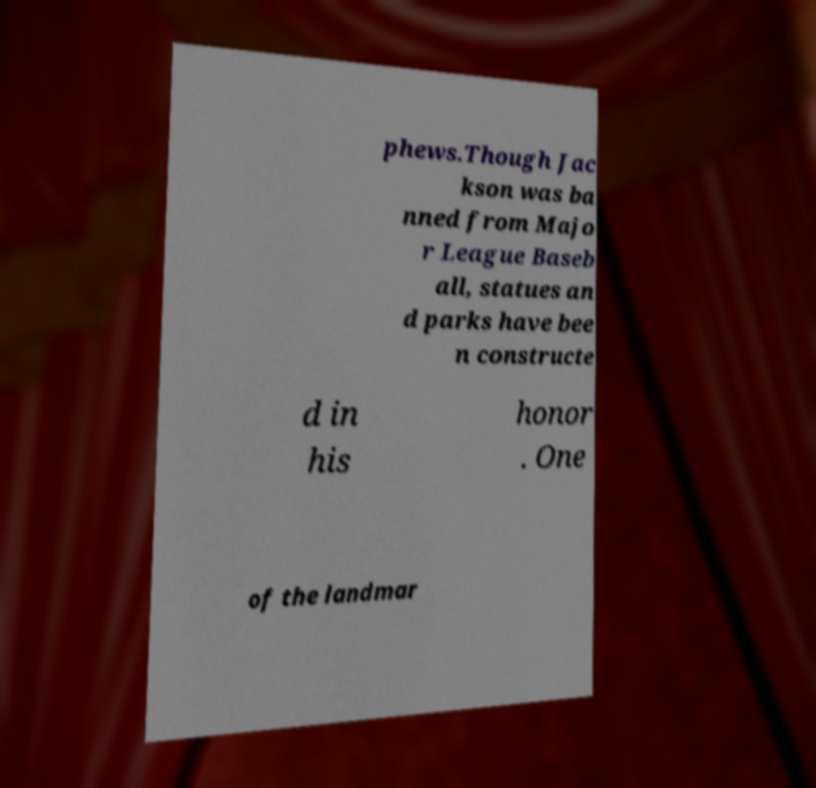Could you extract and type out the text from this image? phews.Though Jac kson was ba nned from Majo r League Baseb all, statues an d parks have bee n constructe d in his honor . One of the landmar 